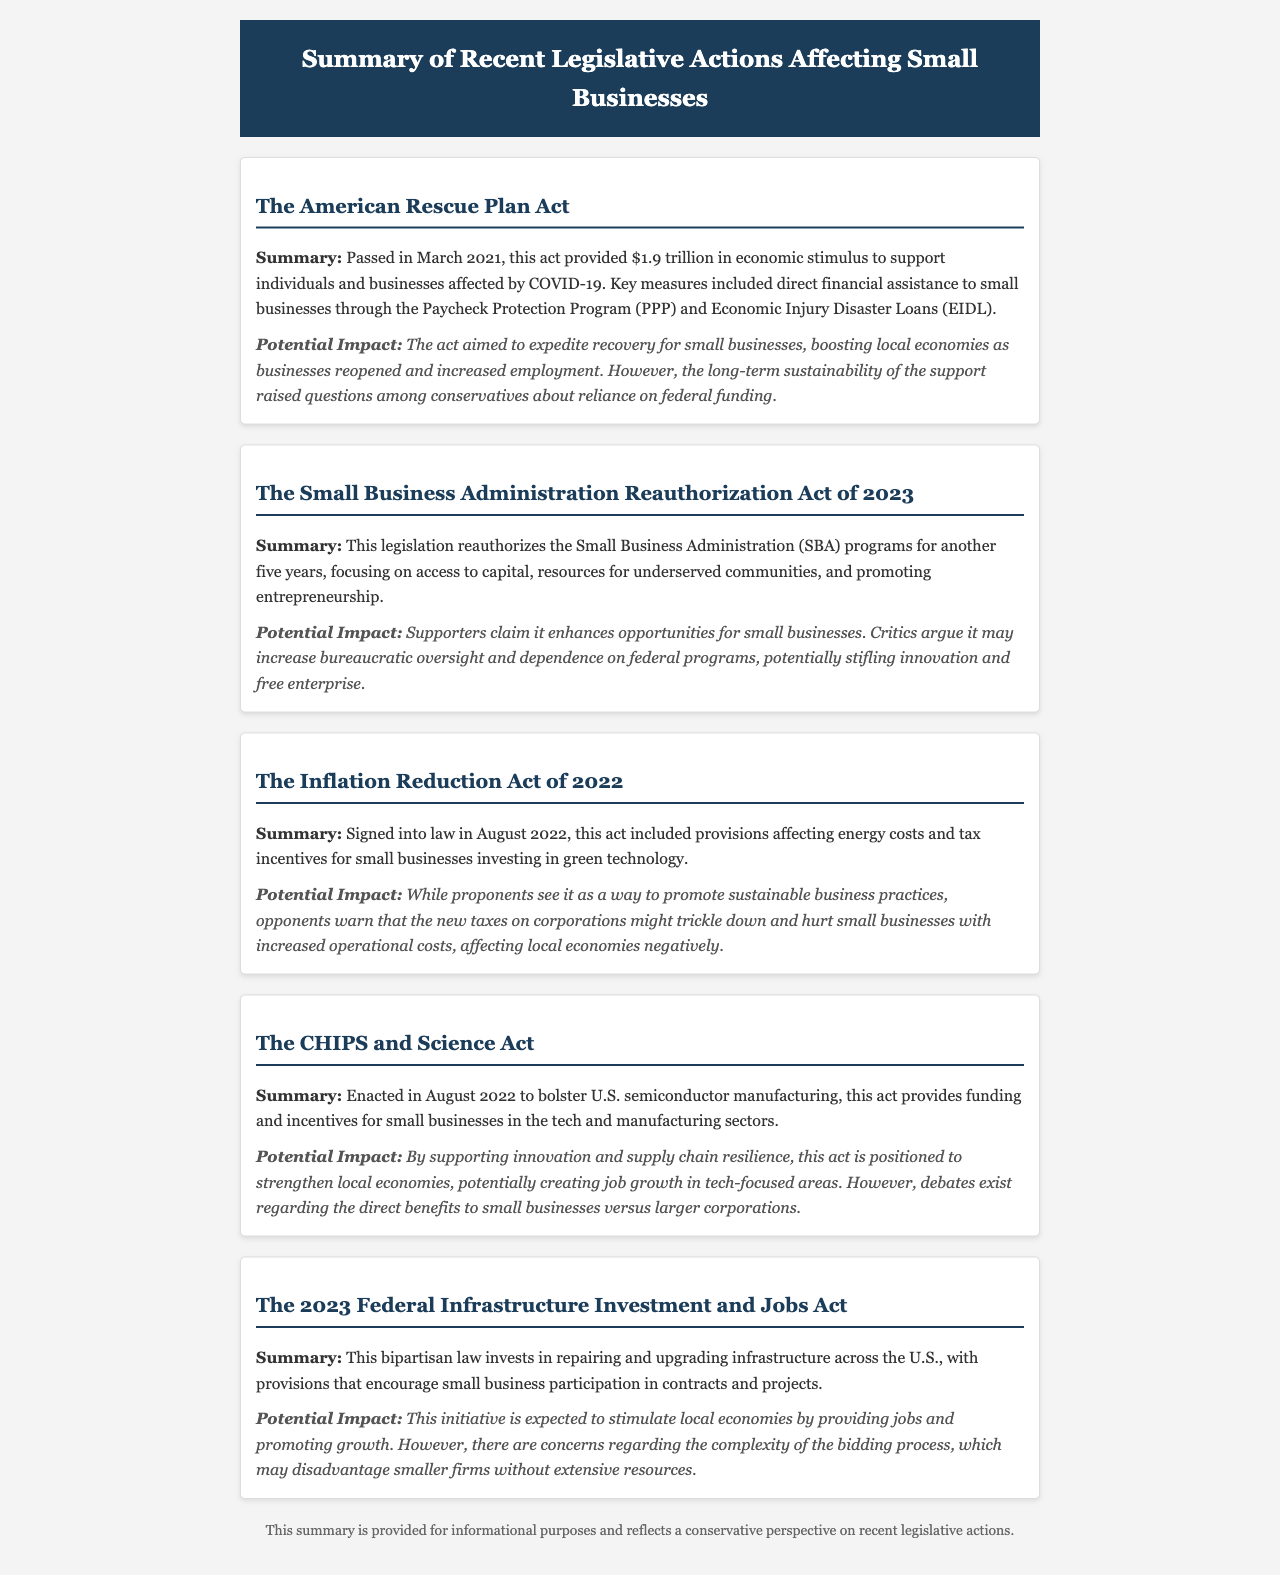What is the total funding provided by The American Rescue Plan Act? The document states that The American Rescue Plan Act provided $1.9 trillion in economic stimulus.
Answer: $1.9 trillion What is one key measure included in The American Rescue Plan Act? The document mentions direct financial assistance through the Paycheck Protection Program (PPP).
Answer: Paycheck Protection Program (PPP) What year was The Small Business Administration Reauthorization Act passed? The document does not explicitly state the exact year, but it mentions the legislation is from 2023.
Answer: 2023 What does the Inflation Reduction Act of 2022 provide for small businesses? The document notes it includes provisions affecting energy costs and tax incentives for investment in green technology.
Answer: Energy costs and tax incentives for green technology What is a potential drawback of the 2023 Federal Infrastructure Investment and Jobs Act? The document highlights concerns regarding the complexity of the bidding process which may disadvantage smaller firms.
Answer: Complexity of the bidding process What focus does The Small Business Administration Reauthorization Act of 2023 have? The legislation focuses on access to capital, resources for underserved communities, and promoting entrepreneurship.
Answer: Access to capital, resources for underserved communities, and promoting entrepreneurship What was a concern raised about the Inflation Reduction Act? The document indicates that opponents warn about new taxes on corporations possibly increasing operational costs for small businesses.
Answer: New taxes on corporations How does The CHIPS and Science Act impact small businesses? The act provides funding and incentives particularly for small businesses in the tech and manufacturing sectors.
Answer: Funding and incentives for tech and manufacturing sectors 